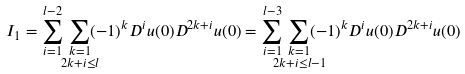Convert formula to latex. <formula><loc_0><loc_0><loc_500><loc_500>& I _ { 1 } = \sum _ { i = 1 } ^ { l - 2 } \, \sum _ { \mathclap { \substack { k = 1 \\ 2 k + i \leq l } } } ( - 1 ) ^ { k } D ^ { i } u ( 0 ) D ^ { 2 k + i } u ( 0 ) = \sum _ { i = 1 } ^ { l - 3 } \, \sum _ { \mathclap { \substack { k = 1 \\ 2 k + i \leq l - 1 } } } ( - 1 ) ^ { k } D ^ { i } u ( 0 ) D ^ { 2 k + i } u ( 0 )</formula> 